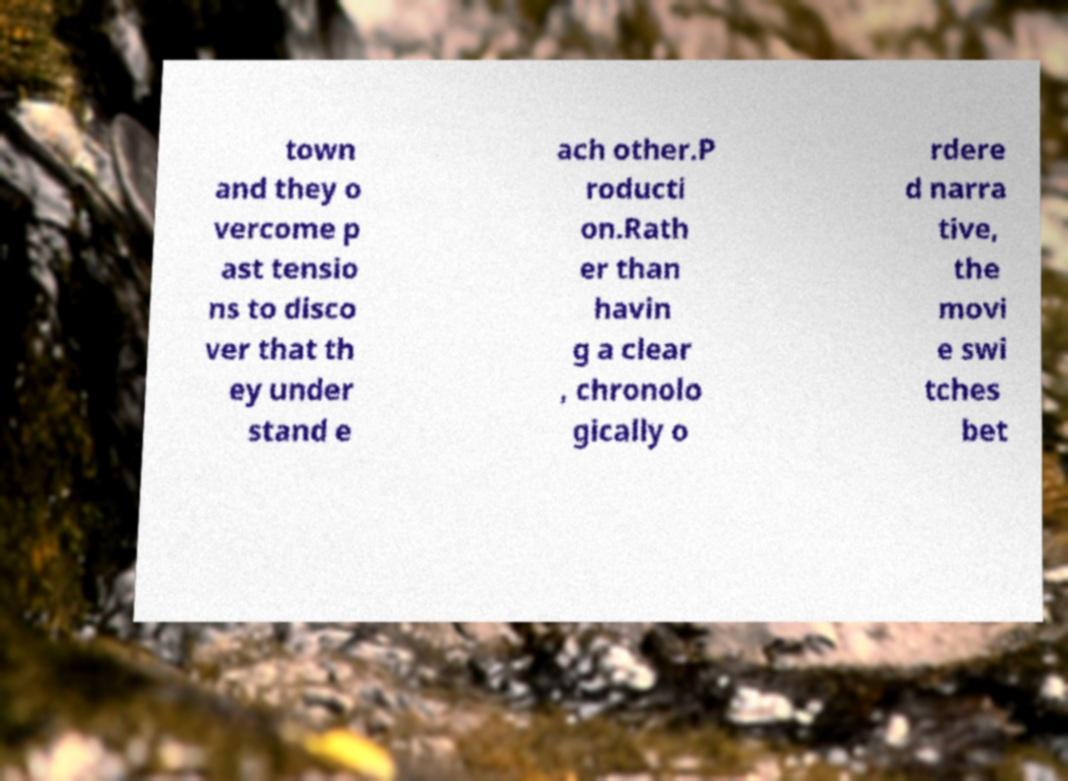I need the written content from this picture converted into text. Can you do that? town and they o vercome p ast tensio ns to disco ver that th ey under stand e ach other.P roducti on.Rath er than havin g a clear , chronolo gically o rdere d narra tive, the movi e swi tches bet 